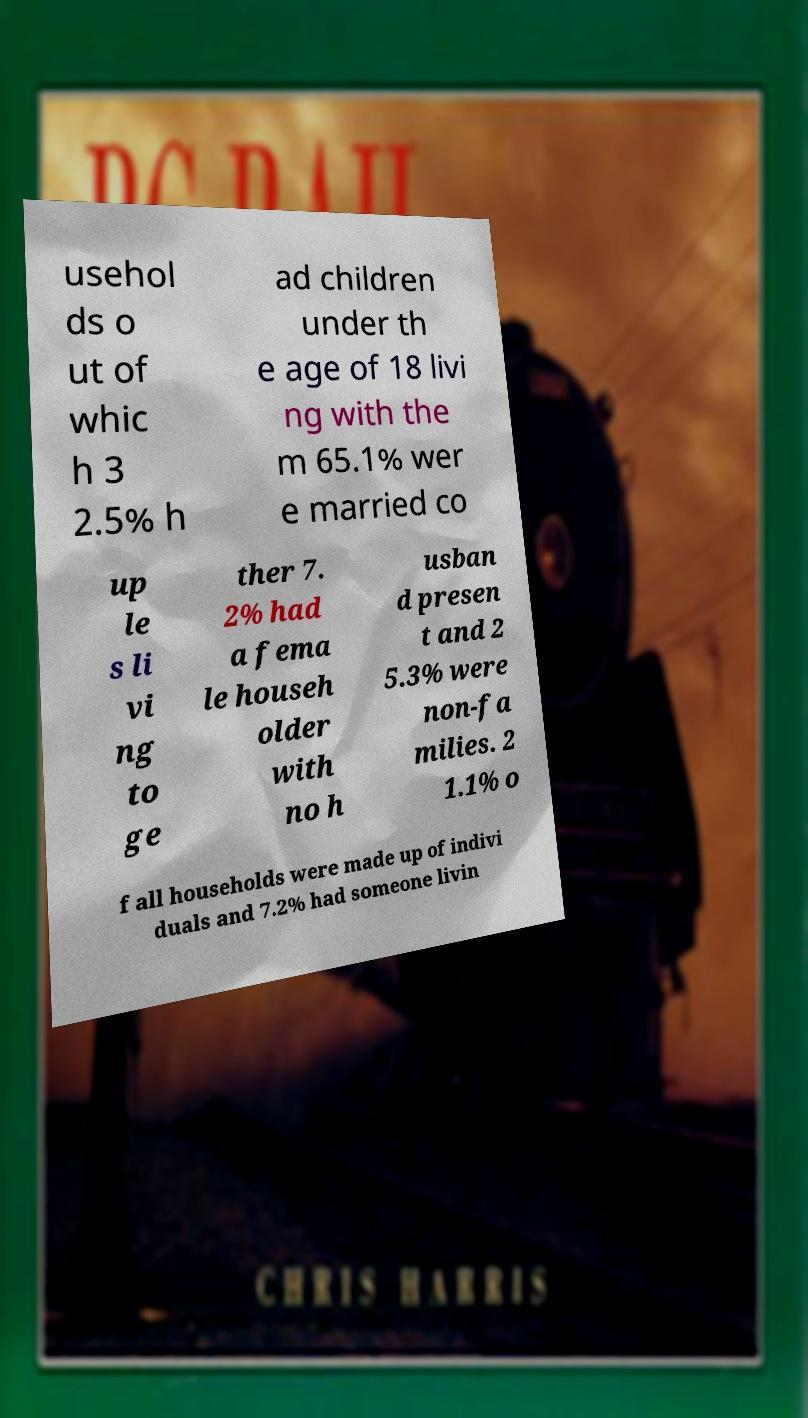Please read and relay the text visible in this image. What does it say? usehol ds o ut of whic h 3 2.5% h ad children under th e age of 18 livi ng with the m 65.1% wer e married co up le s li vi ng to ge ther 7. 2% had a fema le househ older with no h usban d presen t and 2 5.3% were non-fa milies. 2 1.1% o f all households were made up of indivi duals and 7.2% had someone livin 